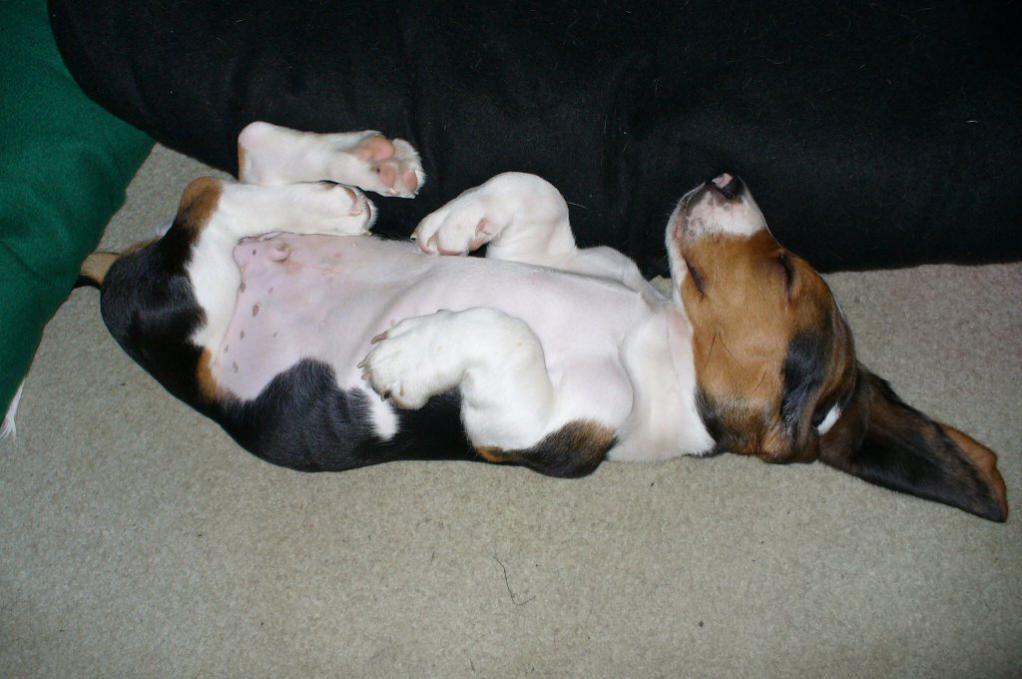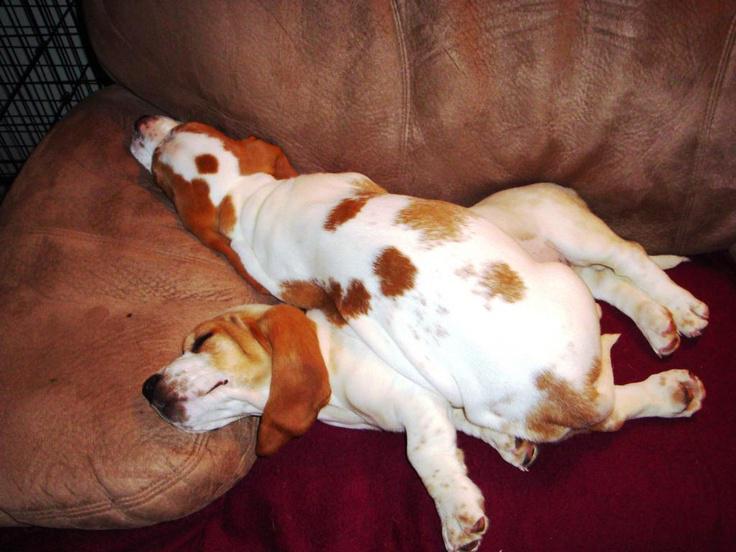The first image is the image on the left, the second image is the image on the right. Analyze the images presented: Is the assertion "There is a single dog sleeping in the image on the left." valid? Answer yes or no. Yes. The first image is the image on the left, the second image is the image on the right. Examine the images to the left and right. Is the description "There is no more than one sleeping dog in the right image." accurate? Answer yes or no. No. 